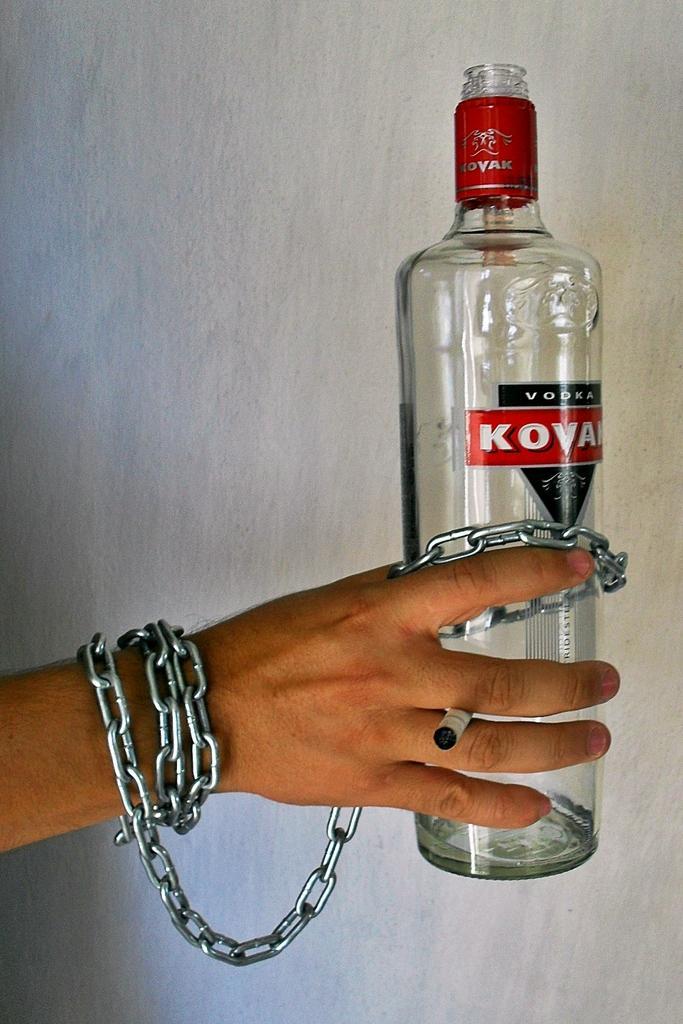Can you describe this image briefly? In this picture a person is holding a bottle and a chain in his hand. 